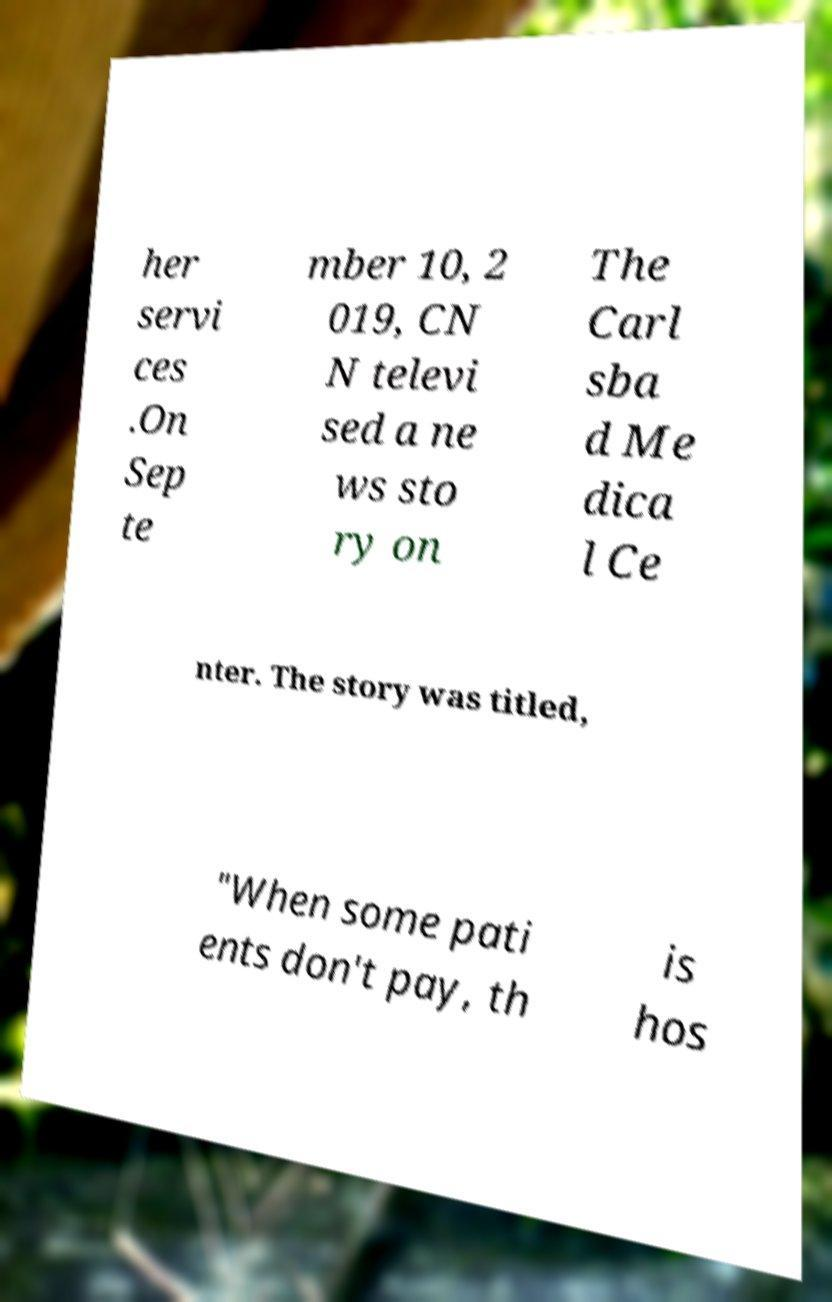There's text embedded in this image that I need extracted. Can you transcribe it verbatim? her servi ces .On Sep te mber 10, 2 019, CN N televi sed a ne ws sto ry on The Carl sba d Me dica l Ce nter. The story was titled, "When some pati ents don't pay, th is hos 